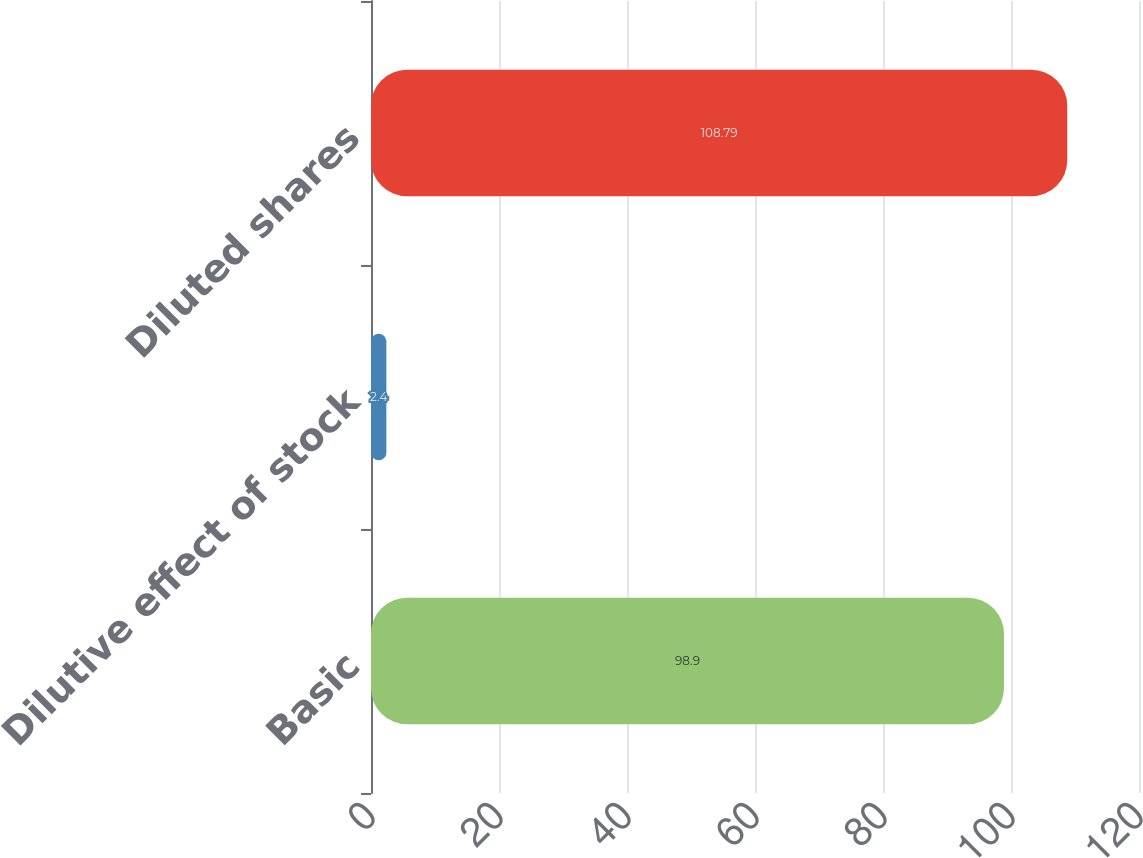<chart> <loc_0><loc_0><loc_500><loc_500><bar_chart><fcel>Basic<fcel>Dilutive effect of stock<fcel>Diluted shares<nl><fcel>98.9<fcel>2.4<fcel>108.79<nl></chart> 